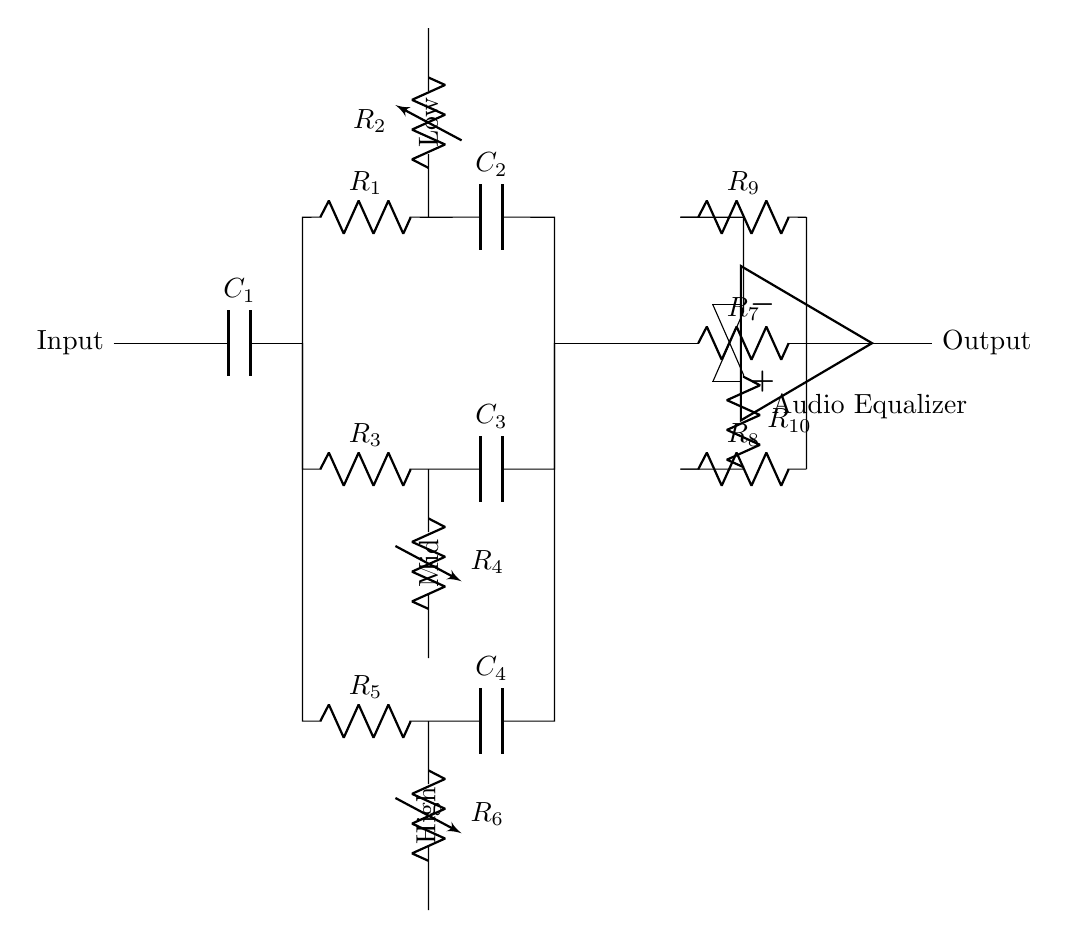What is the purpose of the capacitors in this circuit? The capacitors, labeled C1, C2, C3, and C4, are used to create frequency-dependent responses, allowing the equalizer to adjust low, mid, and high frequencies selectively.
Answer: Frequency response adjustment What type of circuit is this? The circuit diagram represents an audio equalizer, which is specifically designed to process audio signals for frequency customization.
Answer: Audio equalizer How many resistors are in the circuit? By counting the resistors labeled R1 through R10, there are a total of 10 resistors present in the circuit.
Answer: Ten resistors What function does the operational amplifier serve in this equalizer? The operational amplifier, denoted by the op-amp symbol, serves as a summing amplifier, combining the output signals from different frequency bands to produce a final output.
Answer: Summing amplifier Which frequency band controls the lowest frequencies? The circuit has a section clearly labeled for the low frequency band containing the components R1 and C2. This indicates it handles signals in the lowest frequency range.
Answer: Low frequency band What is the label of the component that influences the high frequencies? The high frequency band is indicated by the elements R5 and C4, which are specified in the circuit as components affecting the adjustment of high frequencies.
Answer: High frequency band What is the relationship between R9 and the output signal? Resistor R9, connected from the output node, acts as part of the feedback path for the operational amplifier, which influences the output signal level based on the incoming frequency adjustments.
Answer: Part of feedback path 